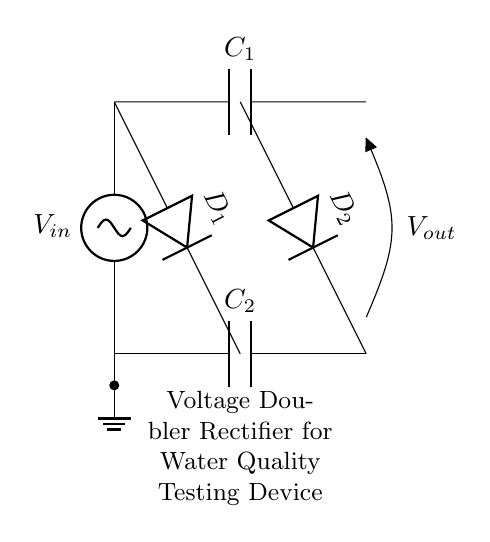What is the input voltage in this circuit? The input voltage is specified as \( V_{in} \) on the left side of the circuit diagram, indicating the source voltage applied to the rectifier.
Answer: \( V_{in} \) How many capacitors are present in the circuit? The circuit diagram shows two capacitors labeled \( C_1 \) and \( C_2 \). They are used to store charge and help in voltage doubling.
Answer: 2 What is the function of diode \( D_1 \)? Diode \( D_1 \) rectifies the AC voltage from the source by allowing current to flow in one direction, contributing to the voltage doubling aspect of the circuit.
Answer: Rectification What is the output voltage in relation to the input voltage? In a voltage doubler rectifier circuit, the output voltage \( V_{out} \) is ideally double the input voltage \( V_{in} \) due to the charge storage and discharge characteristics of the capacitors and diodes.
Answer: \( 2V_{in} \) Which component is responsible for storing energy in the circuit? The capacitors \( C_1 \) and \( C_2 \) are the components responsible for storing electrical energy in the circuit. They charge during the positive half cycle and discharge during the negative half cycle to provide a higher output voltage.
Answer: Capacitors What role does the ground play in this circuit? The ground provides a reference point for the circuit's voltage levels and completes the circuit path for current flow, ensuring proper operation of the components.
Answer: Reference point What type of rectifier is represented by this circuit? The circuit is specifically a voltage doubler rectifier because it uses capacitors and diodes to convert AC voltage into a higher DC output voltage by doubling it.
Answer: Voltage doubler rectifier 